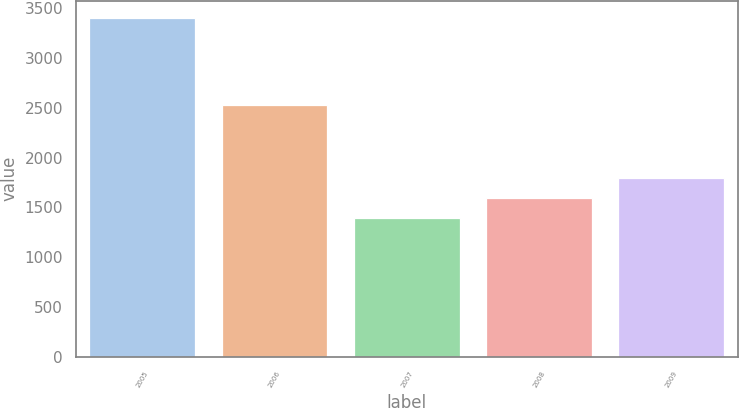Convert chart. <chart><loc_0><loc_0><loc_500><loc_500><bar_chart><fcel>2005<fcel>2006<fcel>2007<fcel>2008<fcel>2009<nl><fcel>3409<fcel>2530<fcel>1391<fcel>1592.8<fcel>1794.6<nl></chart> 